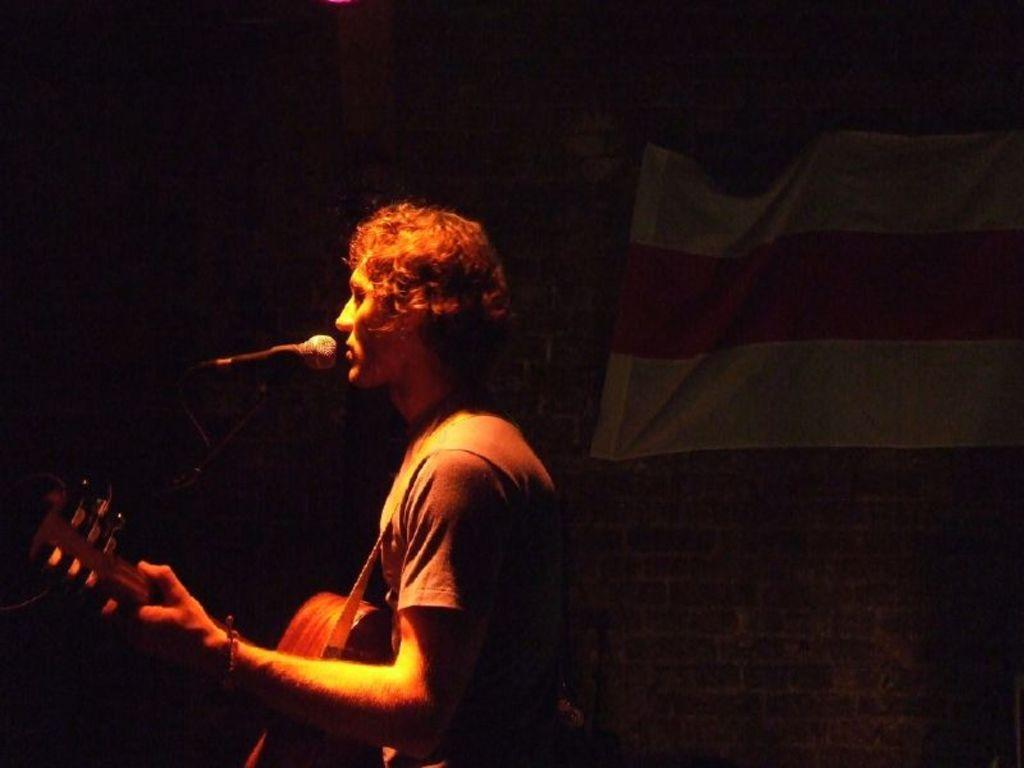What is the man in the image doing? The man is playing a guitar. Can you describe the setting in which the man is performing? The man is in front of a microphone. What type of offer is the man making to the police in the image? There is no police officer present in the image, and the man is not making any offers. What type of cabbage is the man holding in the image? The man is not holding any cabbage in the image; he is playing a guitar. 